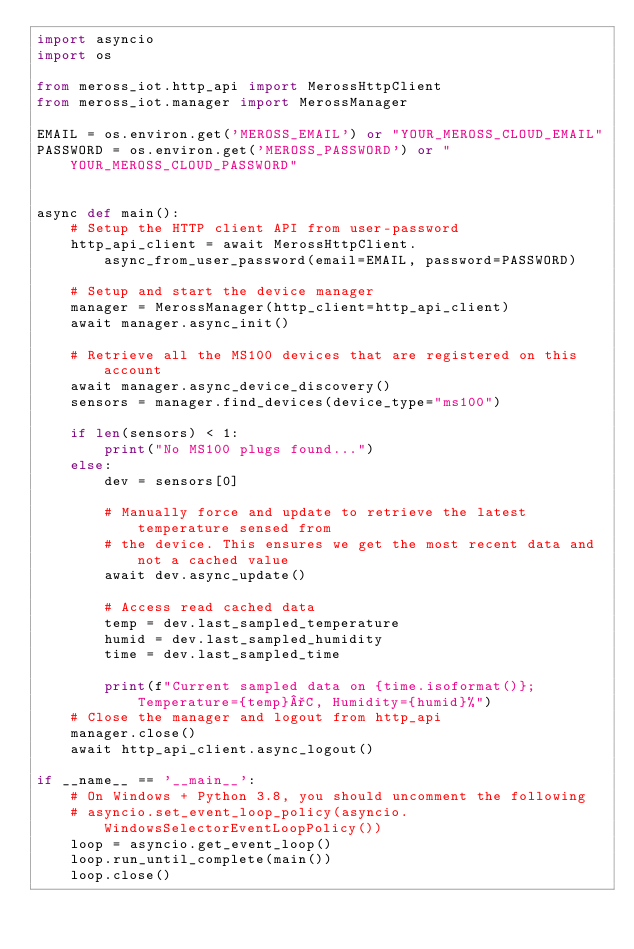Convert code to text. <code><loc_0><loc_0><loc_500><loc_500><_Python_>import asyncio
import os

from meross_iot.http_api import MerossHttpClient
from meross_iot.manager import MerossManager

EMAIL = os.environ.get('MEROSS_EMAIL') or "YOUR_MEROSS_CLOUD_EMAIL"
PASSWORD = os.environ.get('MEROSS_PASSWORD') or "YOUR_MEROSS_CLOUD_PASSWORD"


async def main():
    # Setup the HTTP client API from user-password
    http_api_client = await MerossHttpClient.async_from_user_password(email=EMAIL, password=PASSWORD)

    # Setup and start the device manager
    manager = MerossManager(http_client=http_api_client)
    await manager.async_init()

    # Retrieve all the MS100 devices that are registered on this account
    await manager.async_device_discovery()
    sensors = manager.find_devices(device_type="ms100")

    if len(sensors) < 1:
        print("No MS100 plugs found...")
    else:
        dev = sensors[0]

        # Manually force and update to retrieve the latest temperature sensed from
        # the device. This ensures we get the most recent data and not a cached value
        await dev.async_update()

        # Access read cached data
        temp = dev.last_sampled_temperature
        humid = dev.last_sampled_humidity
        time = dev.last_sampled_time

        print(f"Current sampled data on {time.isoformat()}; Temperature={temp}°C, Humidity={humid}%")
    # Close the manager and logout from http_api
    manager.close()
    await http_api_client.async_logout()

if __name__ == '__main__':
    # On Windows + Python 3.8, you should uncomment the following
    # asyncio.set_event_loop_policy(asyncio.WindowsSelectorEventLoopPolicy())
    loop = asyncio.get_event_loop()
    loop.run_until_complete(main())
    loop.close()
</code> 